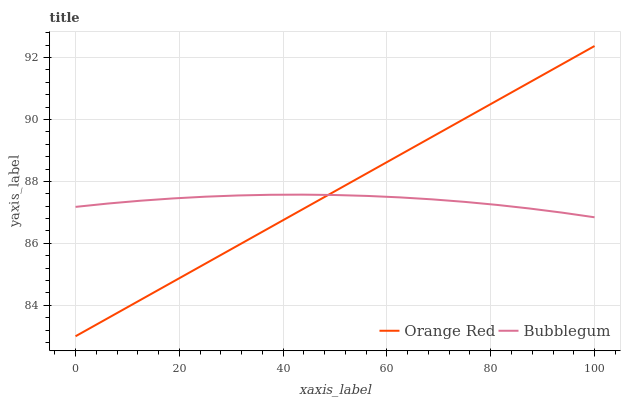Does Bubblegum have the minimum area under the curve?
Answer yes or no. Yes. Does Orange Red have the maximum area under the curve?
Answer yes or no. Yes. Does Bubblegum have the maximum area under the curve?
Answer yes or no. No. Is Orange Red the smoothest?
Answer yes or no. Yes. Is Bubblegum the roughest?
Answer yes or no. Yes. Is Bubblegum the smoothest?
Answer yes or no. No. Does Orange Red have the lowest value?
Answer yes or no. Yes. Does Bubblegum have the lowest value?
Answer yes or no. No. Does Orange Red have the highest value?
Answer yes or no. Yes. Does Bubblegum have the highest value?
Answer yes or no. No. Does Orange Red intersect Bubblegum?
Answer yes or no. Yes. Is Orange Red less than Bubblegum?
Answer yes or no. No. Is Orange Red greater than Bubblegum?
Answer yes or no. No. 